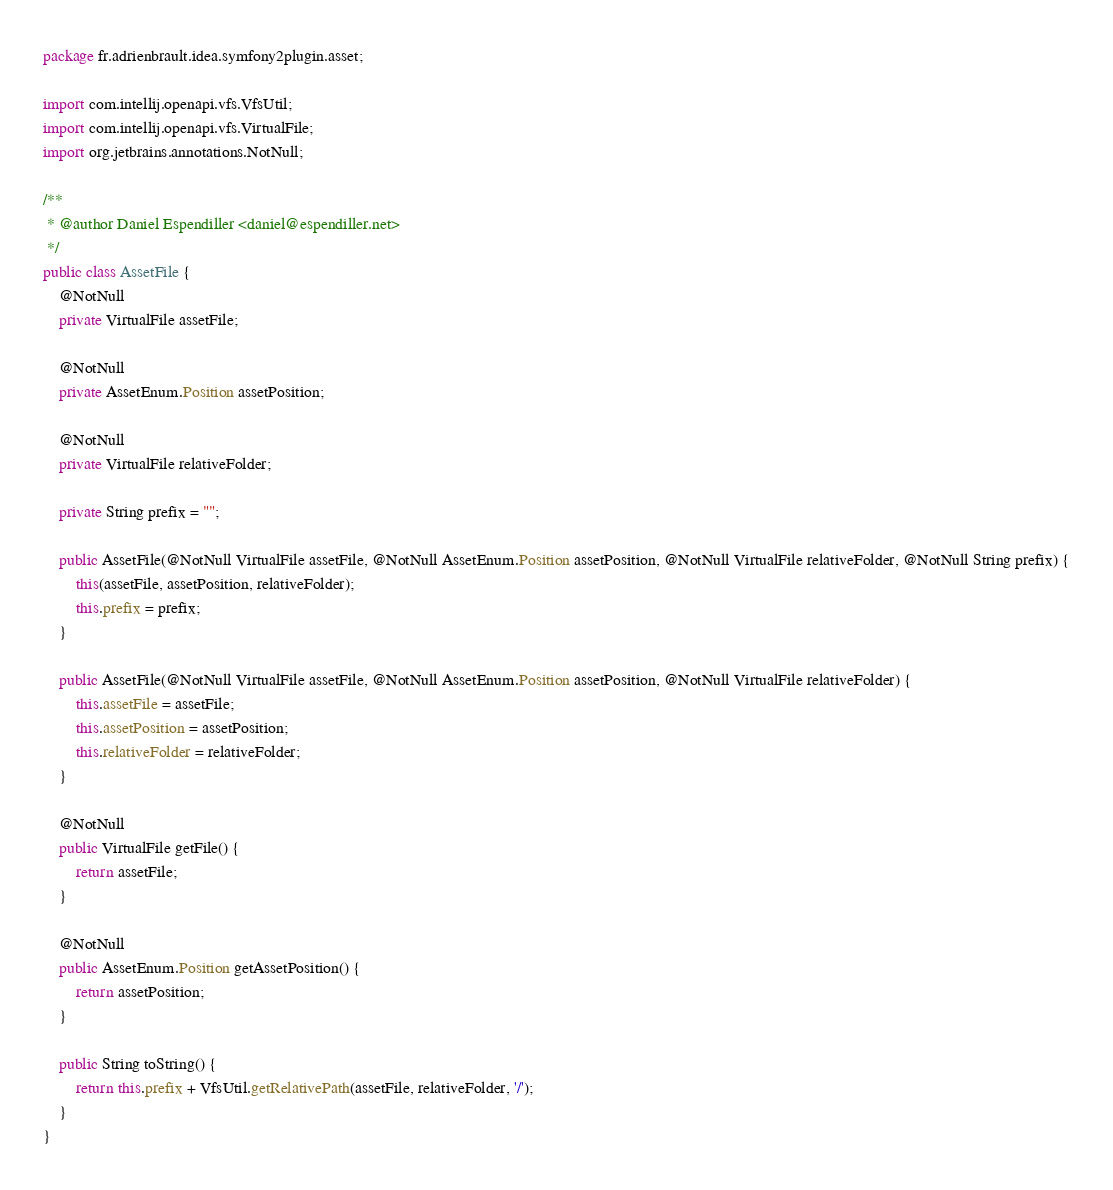<code> <loc_0><loc_0><loc_500><loc_500><_Java_>package fr.adrienbrault.idea.symfony2plugin.asset;

import com.intellij.openapi.vfs.VfsUtil;
import com.intellij.openapi.vfs.VirtualFile;
import org.jetbrains.annotations.NotNull;

/**
 * @author Daniel Espendiller <daniel@espendiller.net>
 */
public class AssetFile {
    @NotNull
    private VirtualFile assetFile;

    @NotNull
    private AssetEnum.Position assetPosition;

    @NotNull
    private VirtualFile relativeFolder;

    private String prefix = "";

    public AssetFile(@NotNull VirtualFile assetFile, @NotNull AssetEnum.Position assetPosition, @NotNull VirtualFile relativeFolder, @NotNull String prefix) {
        this(assetFile, assetPosition, relativeFolder);
        this.prefix = prefix;
    }

    public AssetFile(@NotNull VirtualFile assetFile, @NotNull AssetEnum.Position assetPosition, @NotNull VirtualFile relativeFolder) {
        this.assetFile = assetFile;
        this.assetPosition = assetPosition;
        this.relativeFolder = relativeFolder;
    }

    @NotNull
    public VirtualFile getFile() {
        return assetFile;
    }

    @NotNull
    public AssetEnum.Position getAssetPosition() {
        return assetPosition;
    }

    public String toString() {
        return this.prefix + VfsUtil.getRelativePath(assetFile, relativeFolder, '/');
    }
}
</code> 